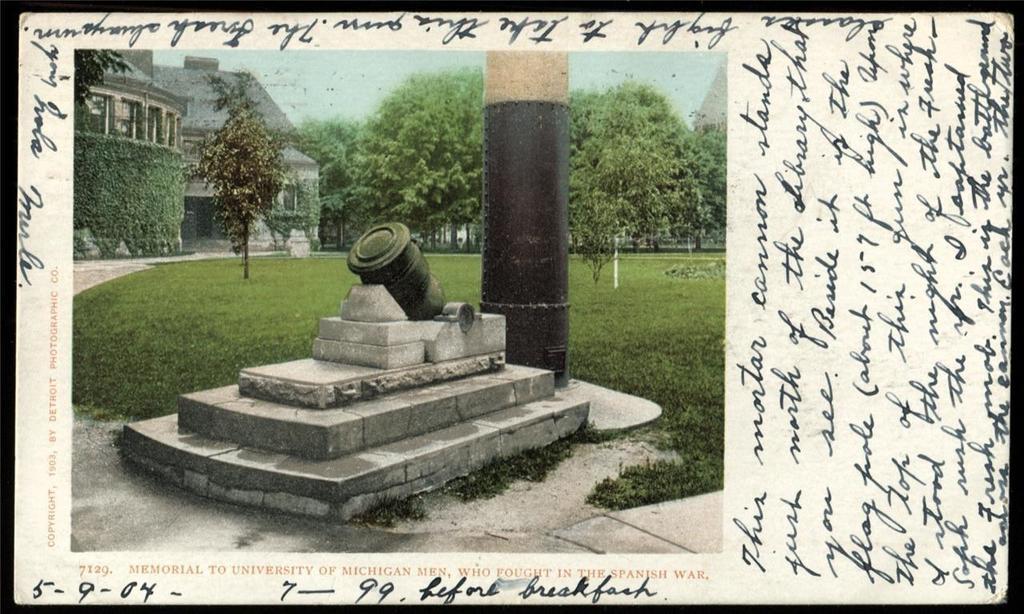Can you describe this image briefly? In this image there is a paper with words, numbers, a photo of house, grass, trees, and sky on the paper. 